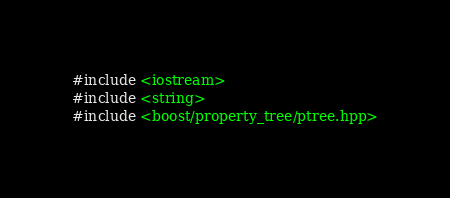Convert code to text. <code><loc_0><loc_0><loc_500><loc_500><_C++_>#include <iostream>
#include <string>
#include <boost/property_tree/ptree.hpp></code> 